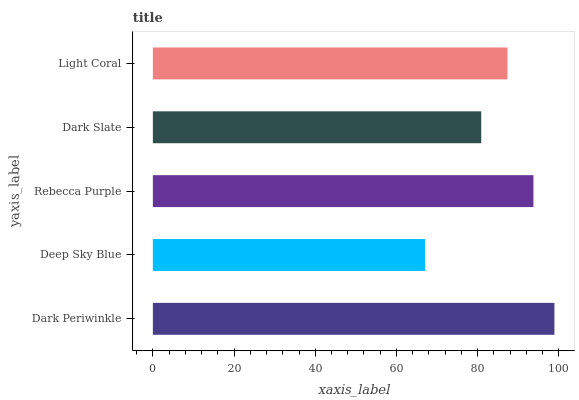Is Deep Sky Blue the minimum?
Answer yes or no. Yes. Is Dark Periwinkle the maximum?
Answer yes or no. Yes. Is Rebecca Purple the minimum?
Answer yes or no. No. Is Rebecca Purple the maximum?
Answer yes or no. No. Is Rebecca Purple greater than Deep Sky Blue?
Answer yes or no. Yes. Is Deep Sky Blue less than Rebecca Purple?
Answer yes or no. Yes. Is Deep Sky Blue greater than Rebecca Purple?
Answer yes or no. No. Is Rebecca Purple less than Deep Sky Blue?
Answer yes or no. No. Is Light Coral the high median?
Answer yes or no. Yes. Is Light Coral the low median?
Answer yes or no. Yes. Is Dark Periwinkle the high median?
Answer yes or no. No. Is Rebecca Purple the low median?
Answer yes or no. No. 